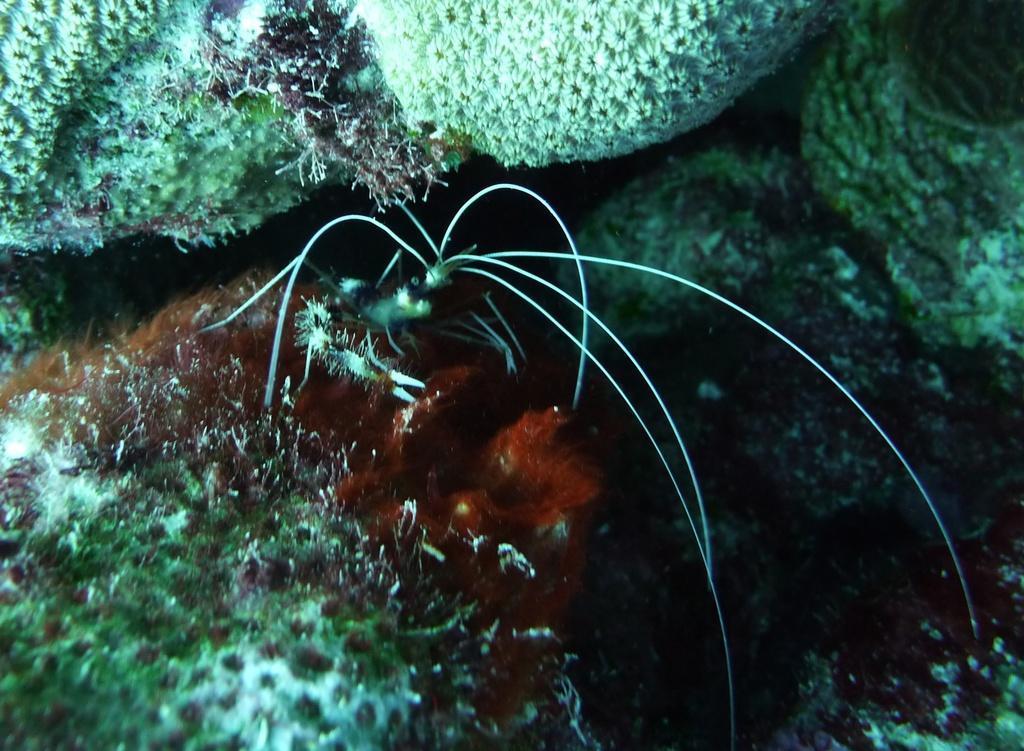Please provide a concise description of this image. in this image there is one insect in middle of this image and there are some water plants in the background. 